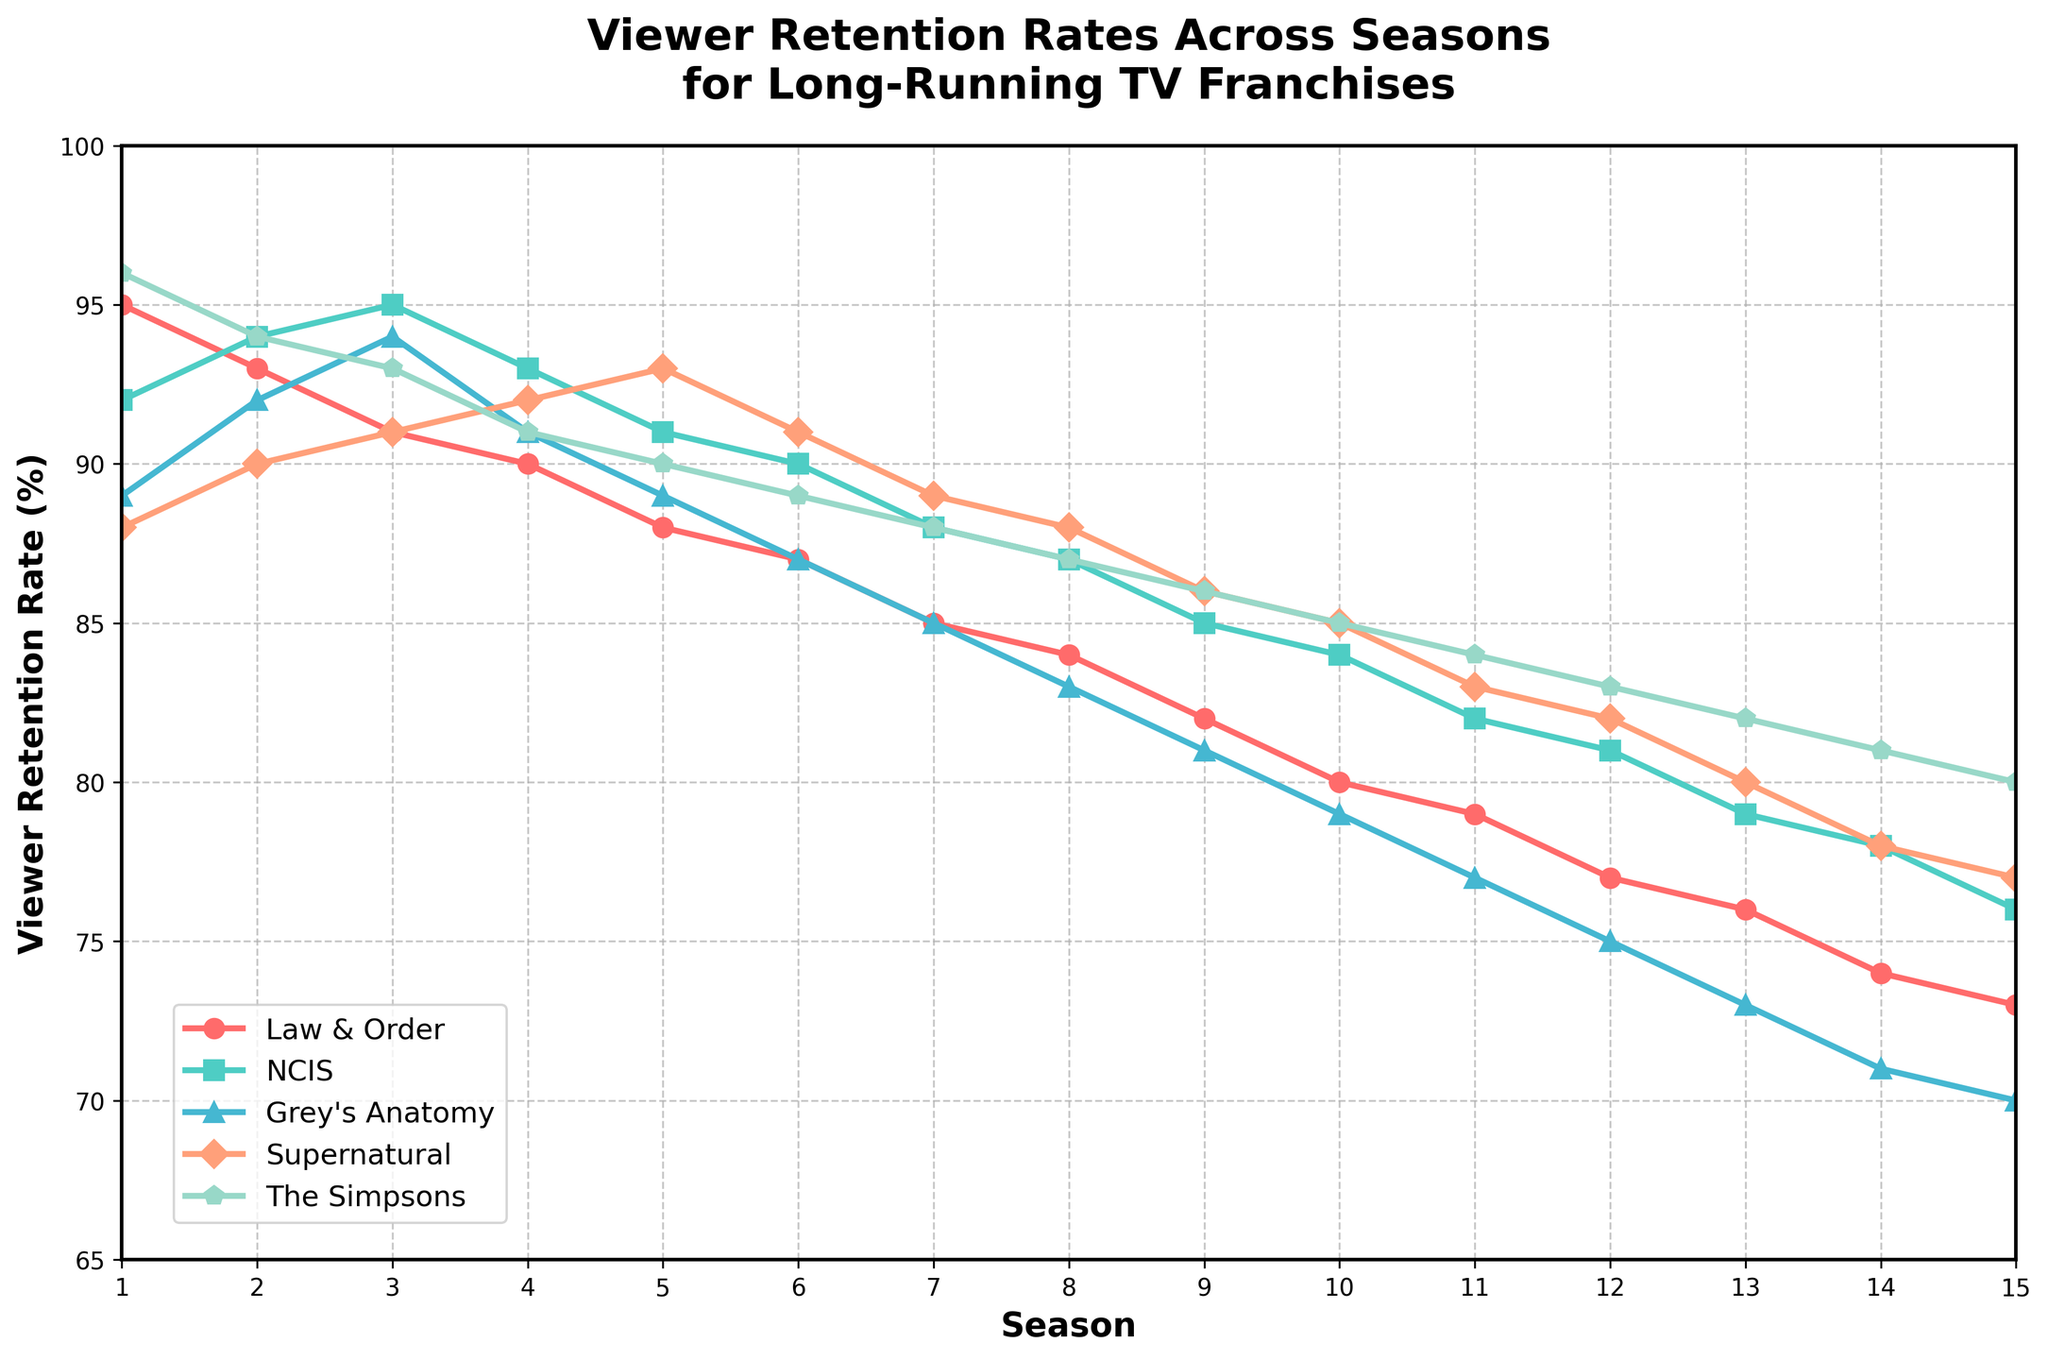What is the viewer retention rate for 'Law & Order' in Season 8? The viewer retention rate for 'Law & Order' in Season 8 is indicated on the y-axis and aligned with Season 8 on the x-axis. According to the plot, it is 84%.
Answer: 84% Which TV show had the highest viewer retention rate in Season 5? By comparing the heights of the lines in Season 5, 'The Simpsons' had the tallest mark, indicating the highest retention rate at 90%.
Answer: The Simpsons Between which two consecutive seasons did 'Grey's Anatomy' see the biggest drop in viewer retention rates? Observing the line for 'Grey's Anatomy', the steepest drop occurs between Seasons 3 and 4 with a difference from 94% to 91%, resulting in a 3% decrease.
Answer: Seasons 3 to 4 What is the average viewer retention rate for 'NCIS' from Season 1 to Season 5? Adding up the viewer retention rates for 'NCIS' from Season 1 to 5 (92 + 94 + 95 + 93 + 91) and then dividing by the number of seasons (5) results in an average of 93.
Answer: 93 How many seasons did 'Supernatural' maintain a viewer retention rate above 80%? Observing the line for 'Supernatural', from Seasons 1 to 15, the rates above 80% end at Season 12. Therefore, the total is 12 seasons.
Answer: 12 What is the difference in retention rate between 'NCIS' and 'Grey's Anatomy' in Season 10? In Season 10, 'NCIS' has a rate of 84%, and 'Grey's Anatomy' has a rate of 79%. The difference is 84% - 79% = 5%.
Answer: 5% Which show had the most significant decrease in retention rate from Season 1 to Season 15? By comparing the start and end points on the graph for each show, 'Grey's Anatomy' goes from 89% in Season 1 to 70% in Season 15, a total decrease of 19%.
Answer: Grey's Anatomy If you average the retention rates for Season 7 across all shows, what is it? Adding the retention rates for all shows in Season 7 (85 + 88 + 85 + 89 + 88) and dividing by 5, we get the average (435 / 5) = 87%.
Answer: 87% 